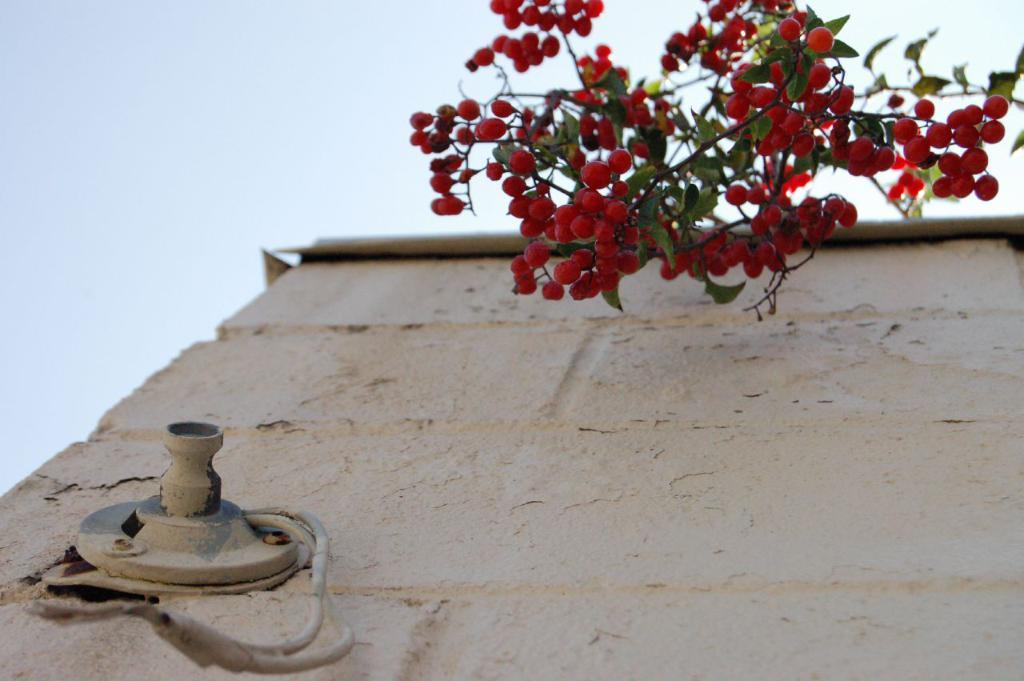What type of structure can be seen in the image? There is a wall in the image. What else is present in the image besides the wall? There is an object and wires visible in the image. Can you describe the fruits in the image? The fruits in the image are red, have stems, and leaves. What can be seen in the background of the image? The sky is visible in the background of the image. Where is the dad playing basketball in the image? There is no dad or basketball present in the image. 